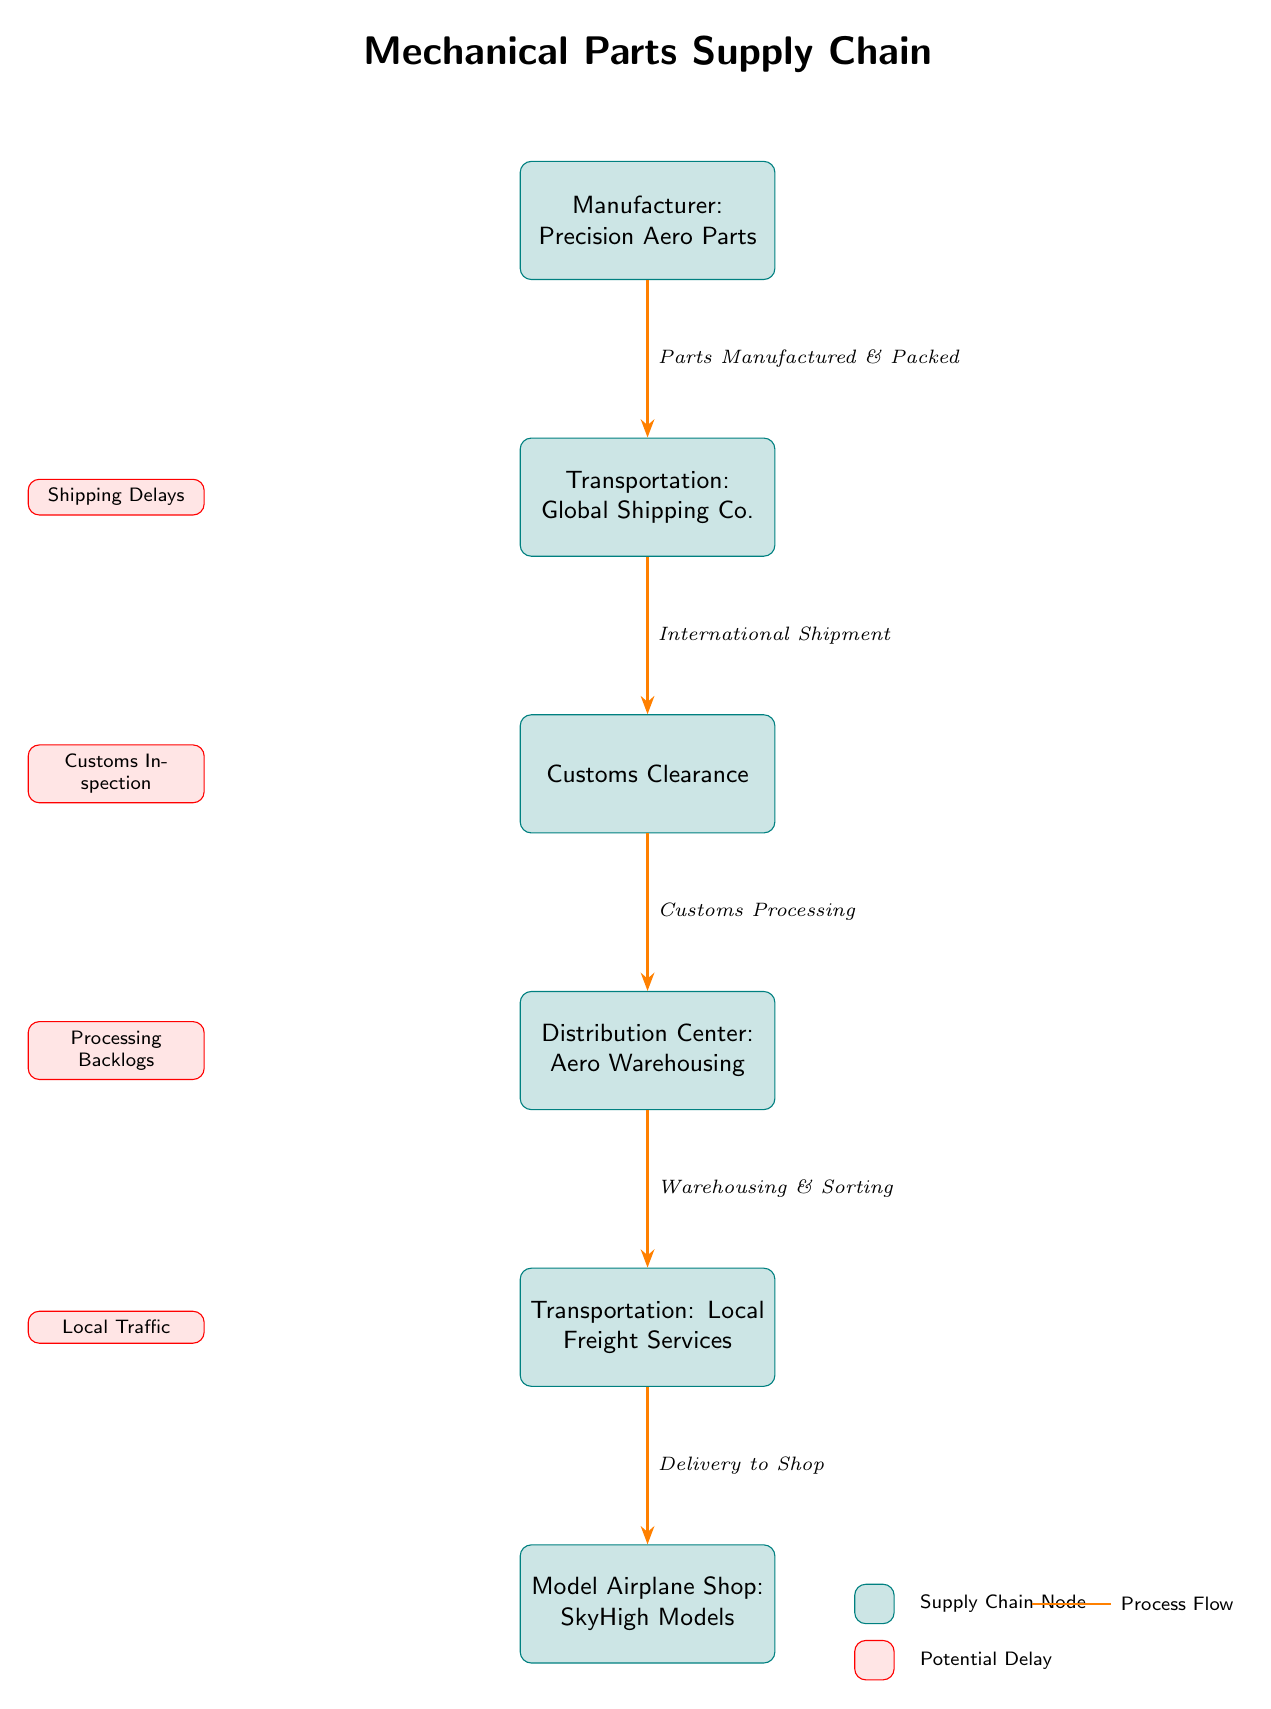What is the first node in the supply chain? The first node in the supply chain is the Manufacturer: Precision Aero Parts, as it is positioned at the top of the diagram and initiates the flow of parts.
Answer: Manufacturer: Precision Aero Parts How many potential delays are highlighted in the diagram? There are four potential delays indicated in the diagram, each represented by a red rectangle labeled with different delay types.
Answer: Four What relationship is shown between the Manufacturer and Transportation? The relationship between the Manufacturer and Transportation is indicated by an arrow pointing from the Manufacturer to Transportation, suggesting that parts are sent from the Manufacturer to the Transportation node for shipping.
Answer: Parts Manufactured & Packed What type of delay is indicated next to Customs? The delay indicated next to Customs is "Customs Inspection," as shown by a red rectangle labeling that specific potential delay associated with the customs process.
Answer: Customs Inspection What is the last node in the supply chain? The last node in the supply chain is the Model Airplane Shop: SkyHigh Models, as it is located at the bottom of the flow diagram where the delivery of parts concludes.
Answer: Model Airplane Shop: SkyHigh Models Which node experiences processing backlogs? The node that experiences processing backlogs is the Distribution Center: Aero Warehousing, as signified by a delay noted next to that particular node in the diagram.
Answer: Distribution Center: Aero Warehousing What is the purpose of the arrow in the diagram? The arrows in the diagram represent the direction of the process flow, indicating how parts move from one node to the next throughout the supply chain.
Answer: Process Flow Which transportation services are used for the initial shipping? The initial shipping is handled by Global Shipping Co., which is designated as the first transportation service in the flow after the Manufacturer.
Answer: Global Shipping Co What does the legend represent at the bottom of the diagram? The legend at the bottom of the diagram represents the types of nodes (supply chain nodes in teal) and potential delays (in red), helping to visually distinguish between them in the supply chain flow.
Answer: Supply Chain Node and Potential Delay 